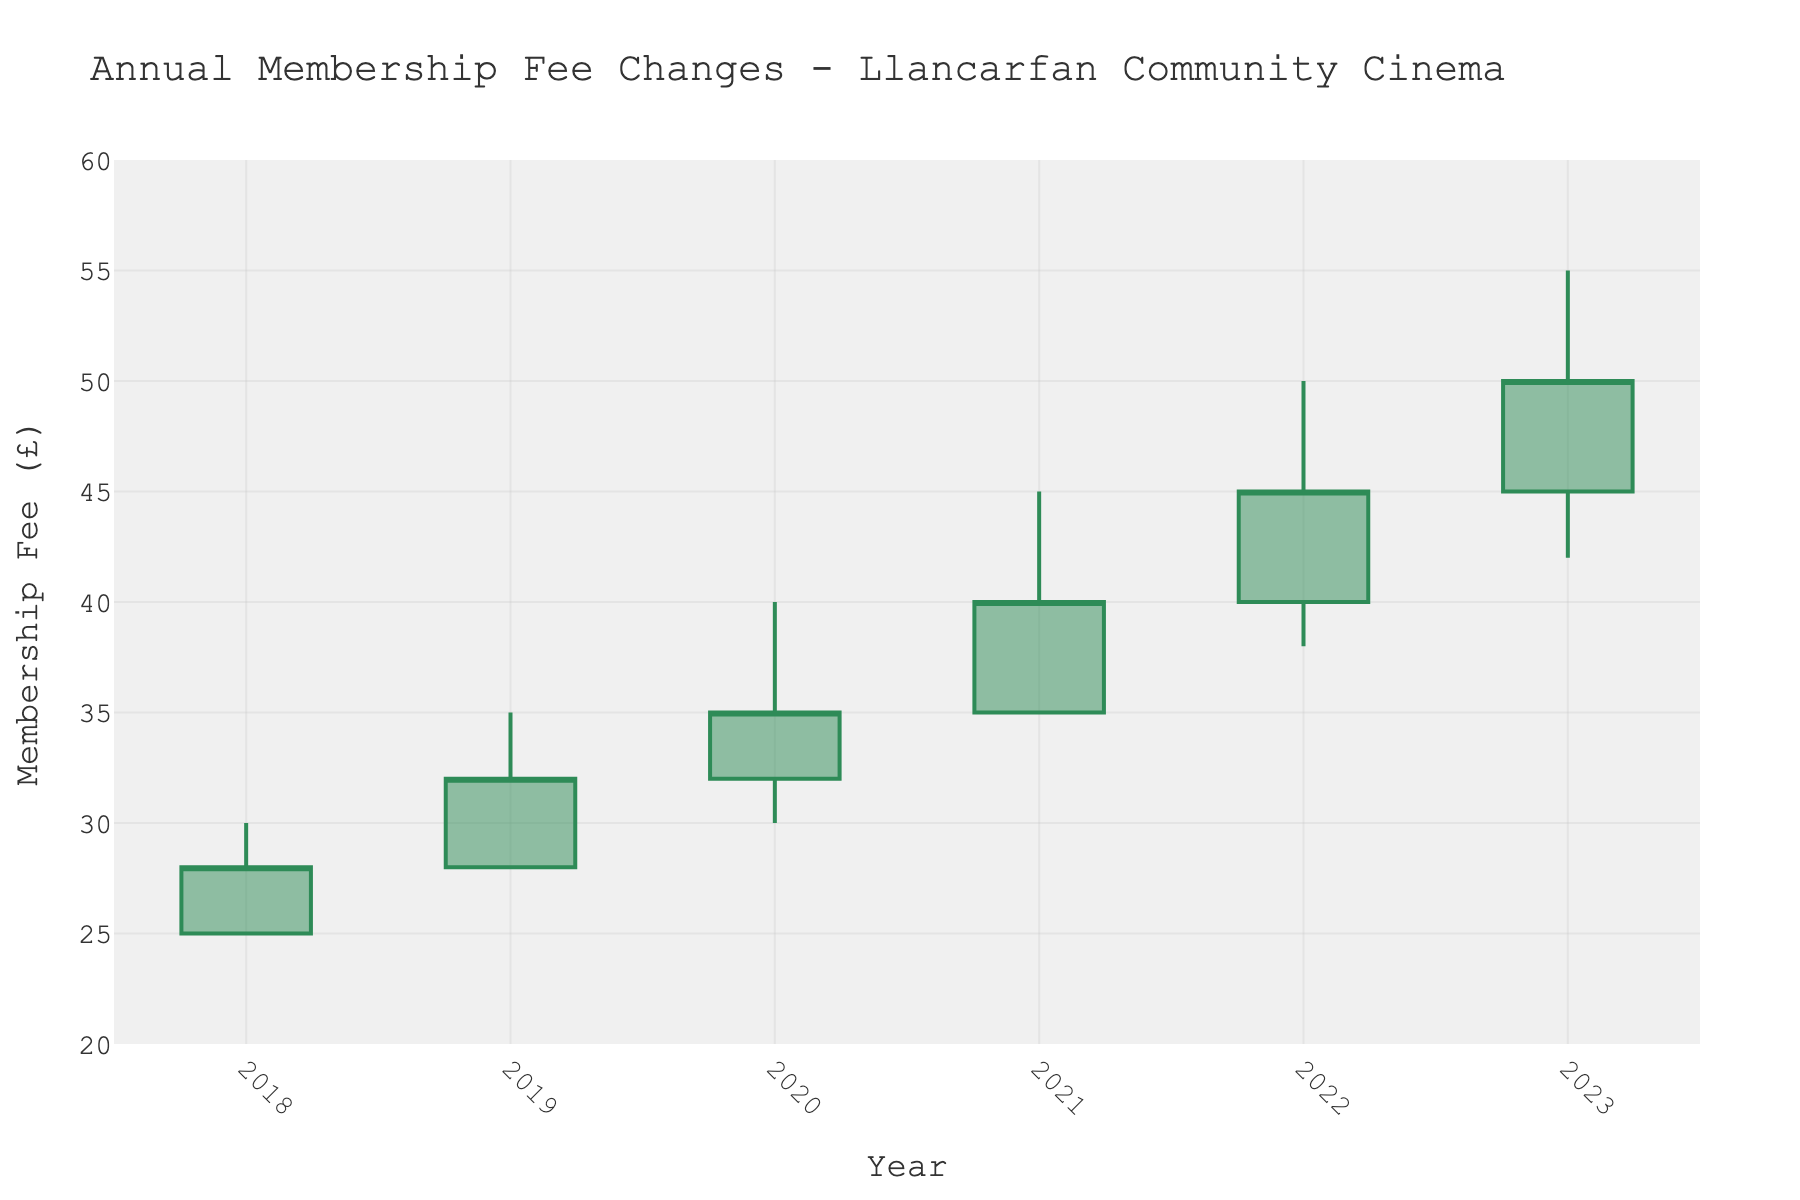How many years are displayed in the plot? The x-axis shows the years ranging from 2018 to 2023. Counting each year, there are six years in total.
Answer: 6 What is the maximum membership fee recorded in the plot? By examining the high values in the candlestick chart, the highest recorded membership fee is £55 in the year 2023.
Answer: £55 Which year experienced the smallest change in the membership fee throughout the year? We check the difference between the high and low values for each year. The smallest change occurs in the year 2018 where the fee varies from £25 to £30, a difference of £5.
Answer: 2018 In which year did the opening membership fee equal the lowest fee for that year? This occurs when the "Opening" and "Low" values are the same. In 2018, the club's fee opened and reached a low of £25.
Answer: 2018 What is the overall percentage increase in the closing membership fee from 2018 to 2023? The closing fee in 2018 was £28 and in 2023 it was £50. The percentage increase is calculated as ((50 - 28) / 28) * 100%. This equals approximately 78.57%.
Answer: 78.57% Which two consecutive years saw the highest increase in the closing membership fee? By comparing the closing values year by year: from 2018 to 2019 = £4, from 2019 to 2020 = £3, from 2020 to 2021 = £5, from 2021 to 2022 = £5, from 2022 to 2023 = £5. The highest increase is between any of the pairs showing an increase of £5 (2020-2021, 2021-2022, 2022-2023).
Answer: 2020 to 2021 What was the closing membership fee in 2021? Looking at the closing values, the membership fee for 2021 closed at £40.
Answer: £40 From 2018 to 2023, identify the year with the lowest opening membership fee. The opening values are £25 (2018), £28 (2019), £32 (2020), £35 (2021), £40 (2022), and £45 (2023). The lowest value is £25 in 2018.
Answer: 2018 Was there any year when the closing membership fee was lower than the opening fee of the same year? We need to compare the opening and closing fees for each year. None had a closing fee less than the opening fee.
Answer: No What color represents an increasing trend in the membership fee, according to the plot? In the plot, the color used to represent an increase in the fee is mentioned as '#2E8B57' which is green.
Answer: Green 